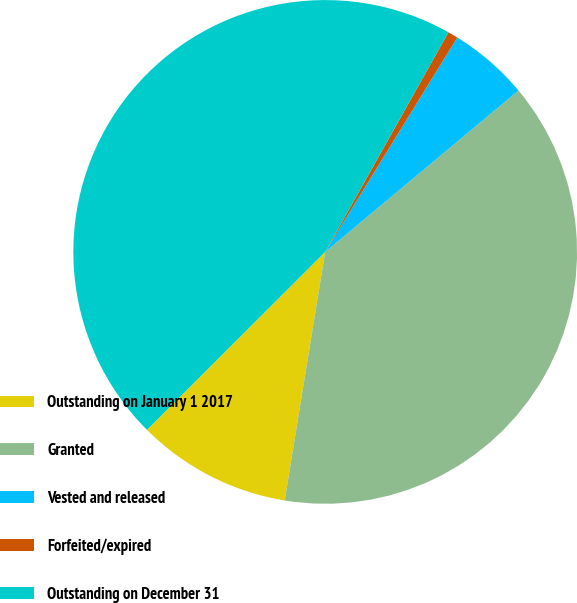<chart> <loc_0><loc_0><loc_500><loc_500><pie_chart><fcel>Outstanding on January 1 2017<fcel>Granted<fcel>Vested and released<fcel>Forfeited/expired<fcel>Outstanding on December 31<nl><fcel>9.94%<fcel>38.64%<fcel>5.14%<fcel>0.65%<fcel>45.63%<nl></chart> 